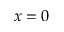Convert formula to latex. <formula><loc_0><loc_0><loc_500><loc_500>x = 0</formula> 